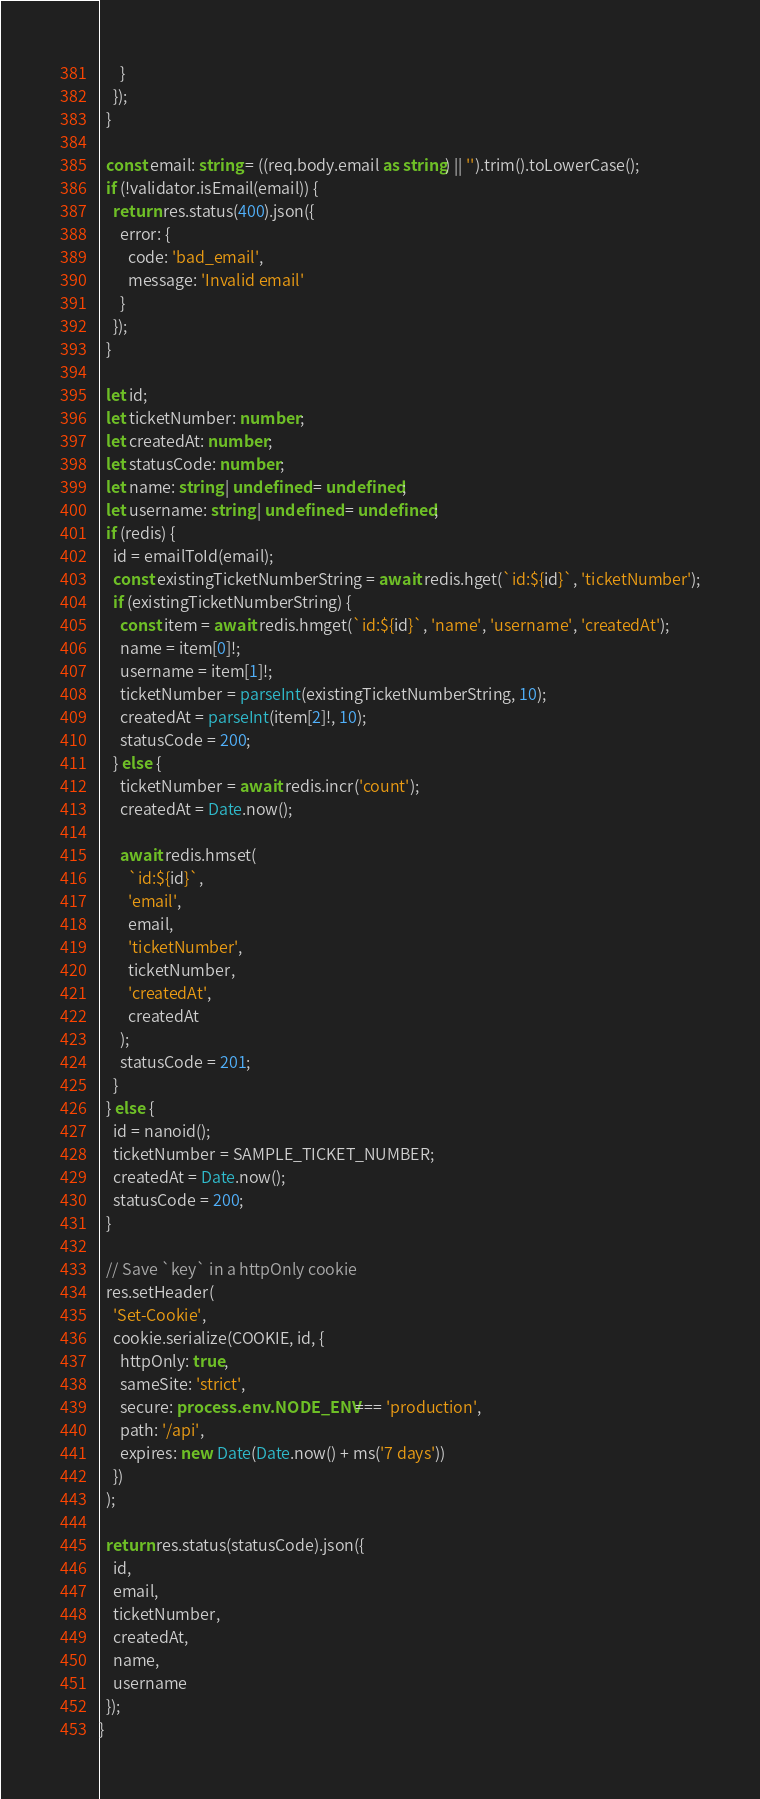Convert code to text. <code><loc_0><loc_0><loc_500><loc_500><_TypeScript_>      }
    });
  }

  const email: string = ((req.body.email as string) || '').trim().toLowerCase();
  if (!validator.isEmail(email)) {
    return res.status(400).json({
      error: {
        code: 'bad_email',
        message: 'Invalid email'
      }
    });
  }

  let id;
  let ticketNumber: number;
  let createdAt: number;
  let statusCode: number;
  let name: string | undefined = undefined;
  let username: string | undefined = undefined;
  if (redis) {
    id = emailToId(email);
    const existingTicketNumberString = await redis.hget(`id:${id}`, 'ticketNumber');
    if (existingTicketNumberString) {
      const item = await redis.hmget(`id:${id}`, 'name', 'username', 'createdAt');
      name = item[0]!;
      username = item[1]!;
      ticketNumber = parseInt(existingTicketNumberString, 10);
      createdAt = parseInt(item[2]!, 10);
      statusCode = 200;
    } else {
      ticketNumber = await redis.incr('count');
      createdAt = Date.now();

      await redis.hmset(
        `id:${id}`,
        'email',
        email,
        'ticketNumber',
        ticketNumber,
        'createdAt',
        createdAt
      );
      statusCode = 201;
    }
  } else {
    id = nanoid();
    ticketNumber = SAMPLE_TICKET_NUMBER;
    createdAt = Date.now();
    statusCode = 200;
  }

  // Save `key` in a httpOnly cookie
  res.setHeader(
    'Set-Cookie',
    cookie.serialize(COOKIE, id, {
      httpOnly: true,
      sameSite: 'strict',
      secure: process.env.NODE_ENV === 'production',
      path: '/api',
      expires: new Date(Date.now() + ms('7 days'))
    })
  );

  return res.status(statusCode).json({
    id,
    email,
    ticketNumber,
    createdAt,
    name,
    username
  });
}
</code> 